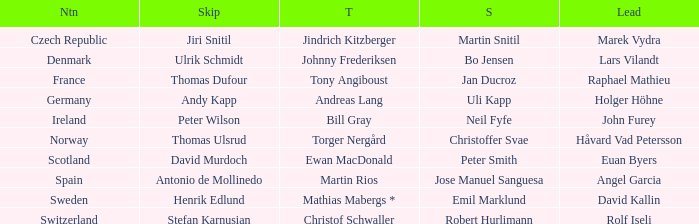Which leader is associated with the nation of switzerland? Rolf Iseli. 